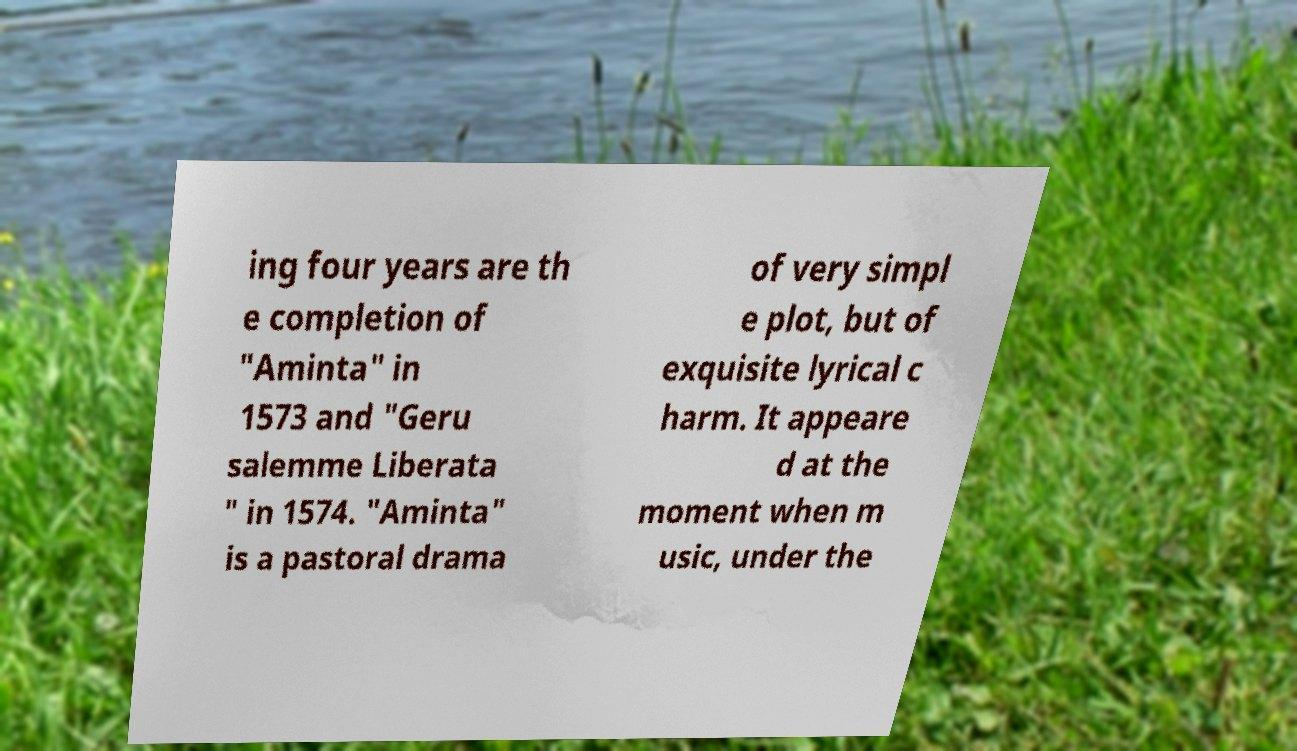Please read and relay the text visible in this image. What does it say? ing four years are th e completion of "Aminta" in 1573 and "Geru salemme Liberata " in 1574. "Aminta" is a pastoral drama of very simpl e plot, but of exquisite lyrical c harm. It appeare d at the moment when m usic, under the 